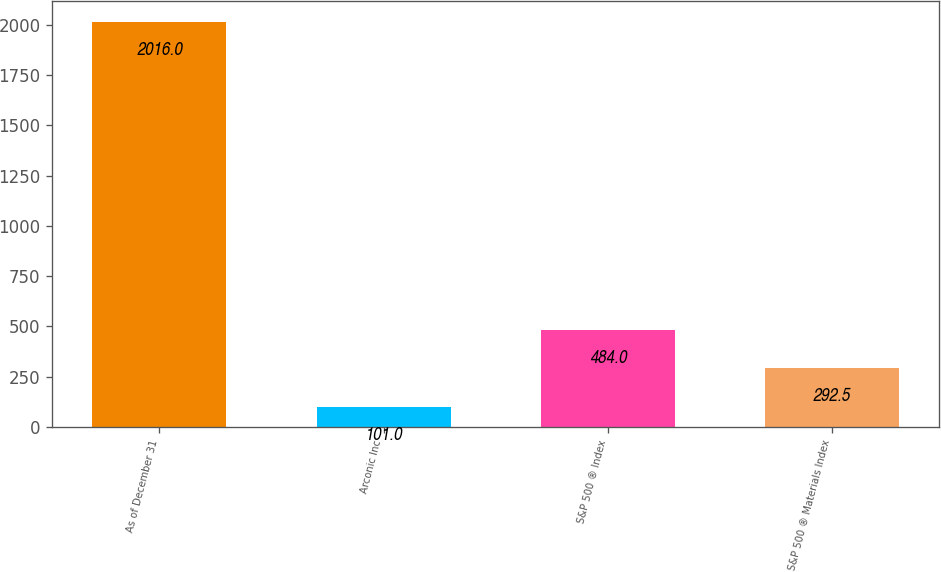Convert chart. <chart><loc_0><loc_0><loc_500><loc_500><bar_chart><fcel>As of December 31<fcel>Arconic Inc<fcel>S&P 500 ® Index<fcel>S&P 500 ® Materials Index<nl><fcel>2016<fcel>101<fcel>484<fcel>292.5<nl></chart> 